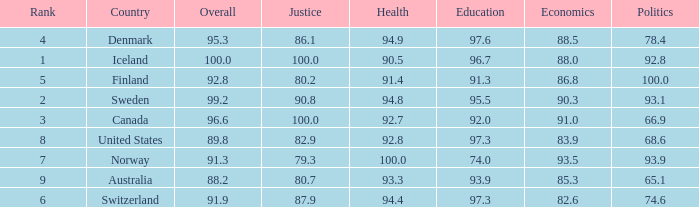What's the economics score with education being 92.0 91.0. 